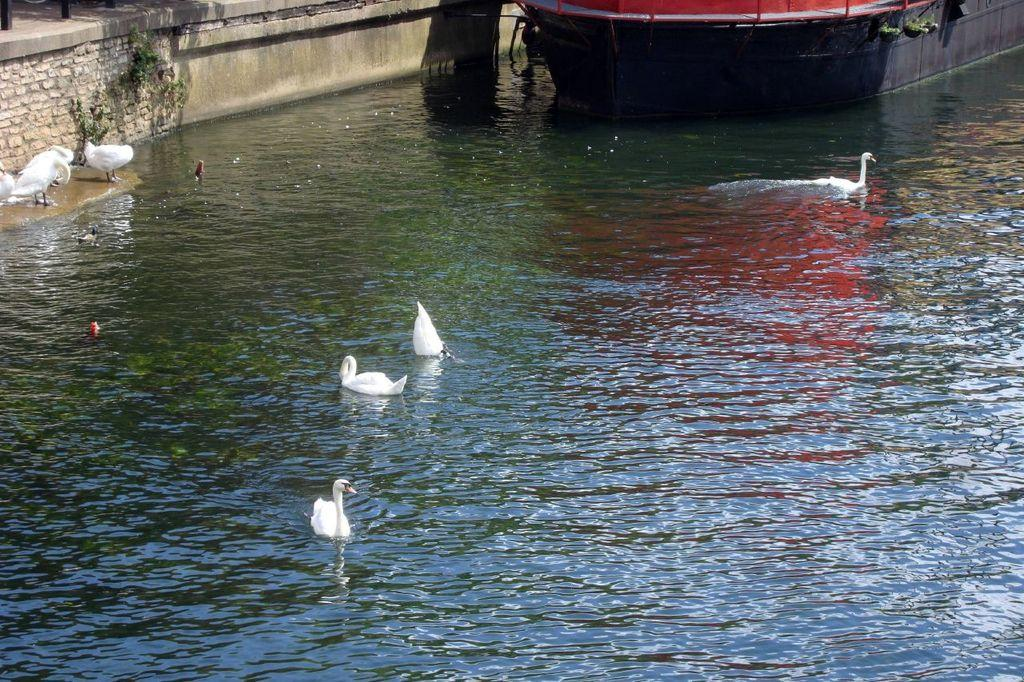What animals can be seen on the water in the image? There are birds on the water in the image. What type of watercraft is present in the image? There is a boat in the image. What structure is located on the left side of the image? There is a wall on the left side of the image. Where else can birds be seen in the image? Birds can also be seen standing on a platform at the water in the image. How many pigs are visible in the image? There are no pigs present in the image. What type of cave can be seen in the image? There is no cave present in the image. 